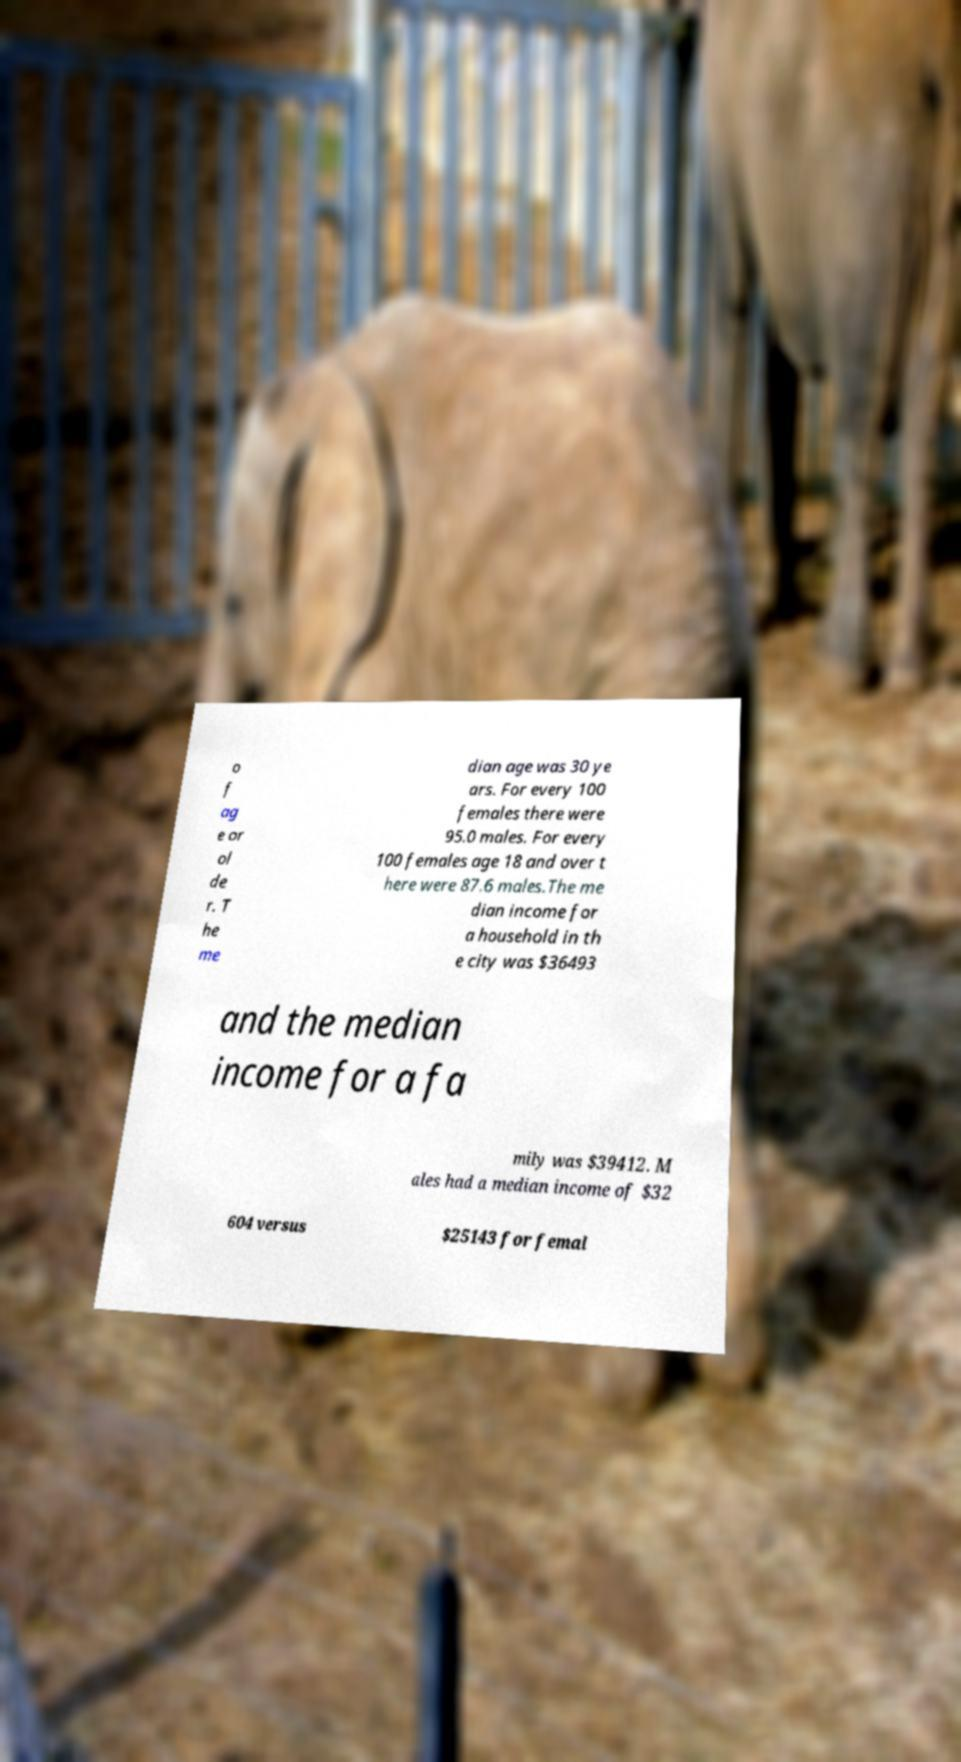For documentation purposes, I need the text within this image transcribed. Could you provide that? o f ag e or ol de r. T he me dian age was 30 ye ars. For every 100 females there were 95.0 males. For every 100 females age 18 and over t here were 87.6 males.The me dian income for a household in th e city was $36493 and the median income for a fa mily was $39412. M ales had a median income of $32 604 versus $25143 for femal 